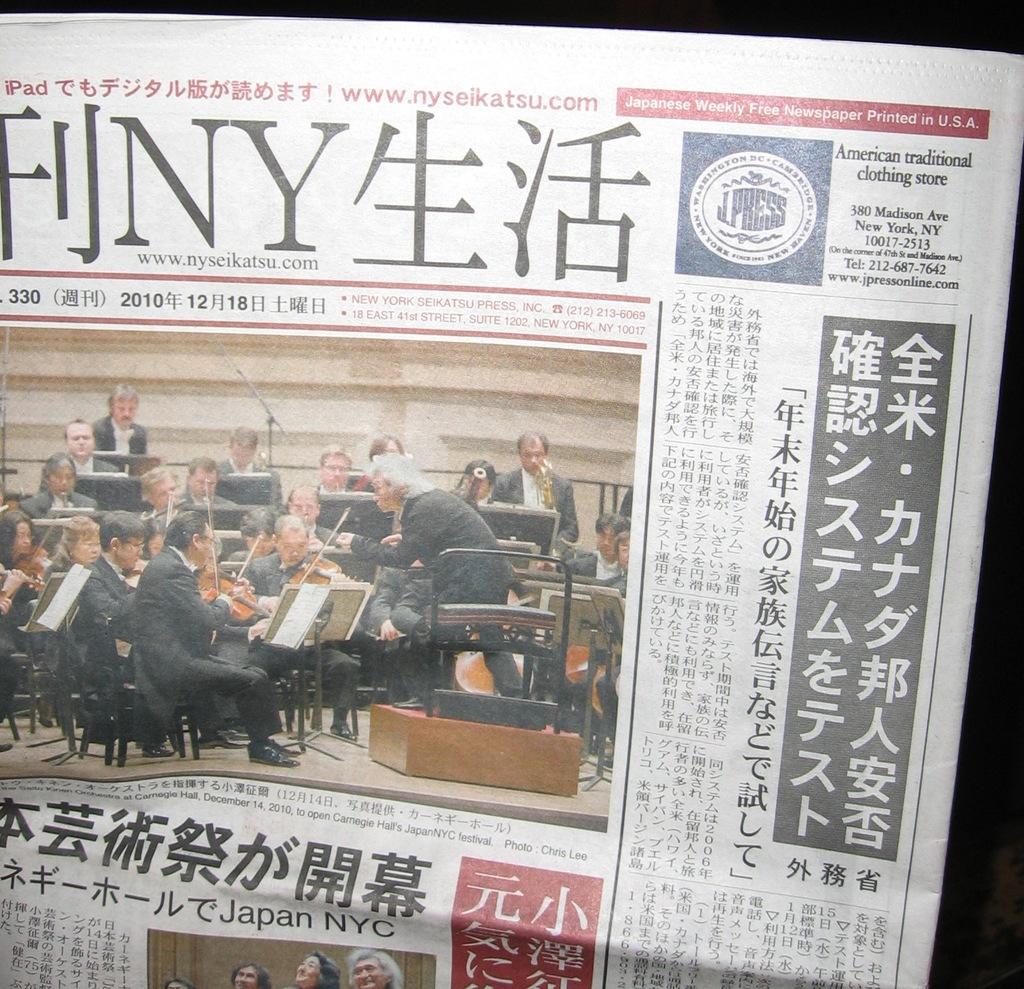Is that an orchestra?
Offer a very short reply. Answering does not require reading text in the image. What date was this paper published?
Your answer should be compact. 12/18/2010. 